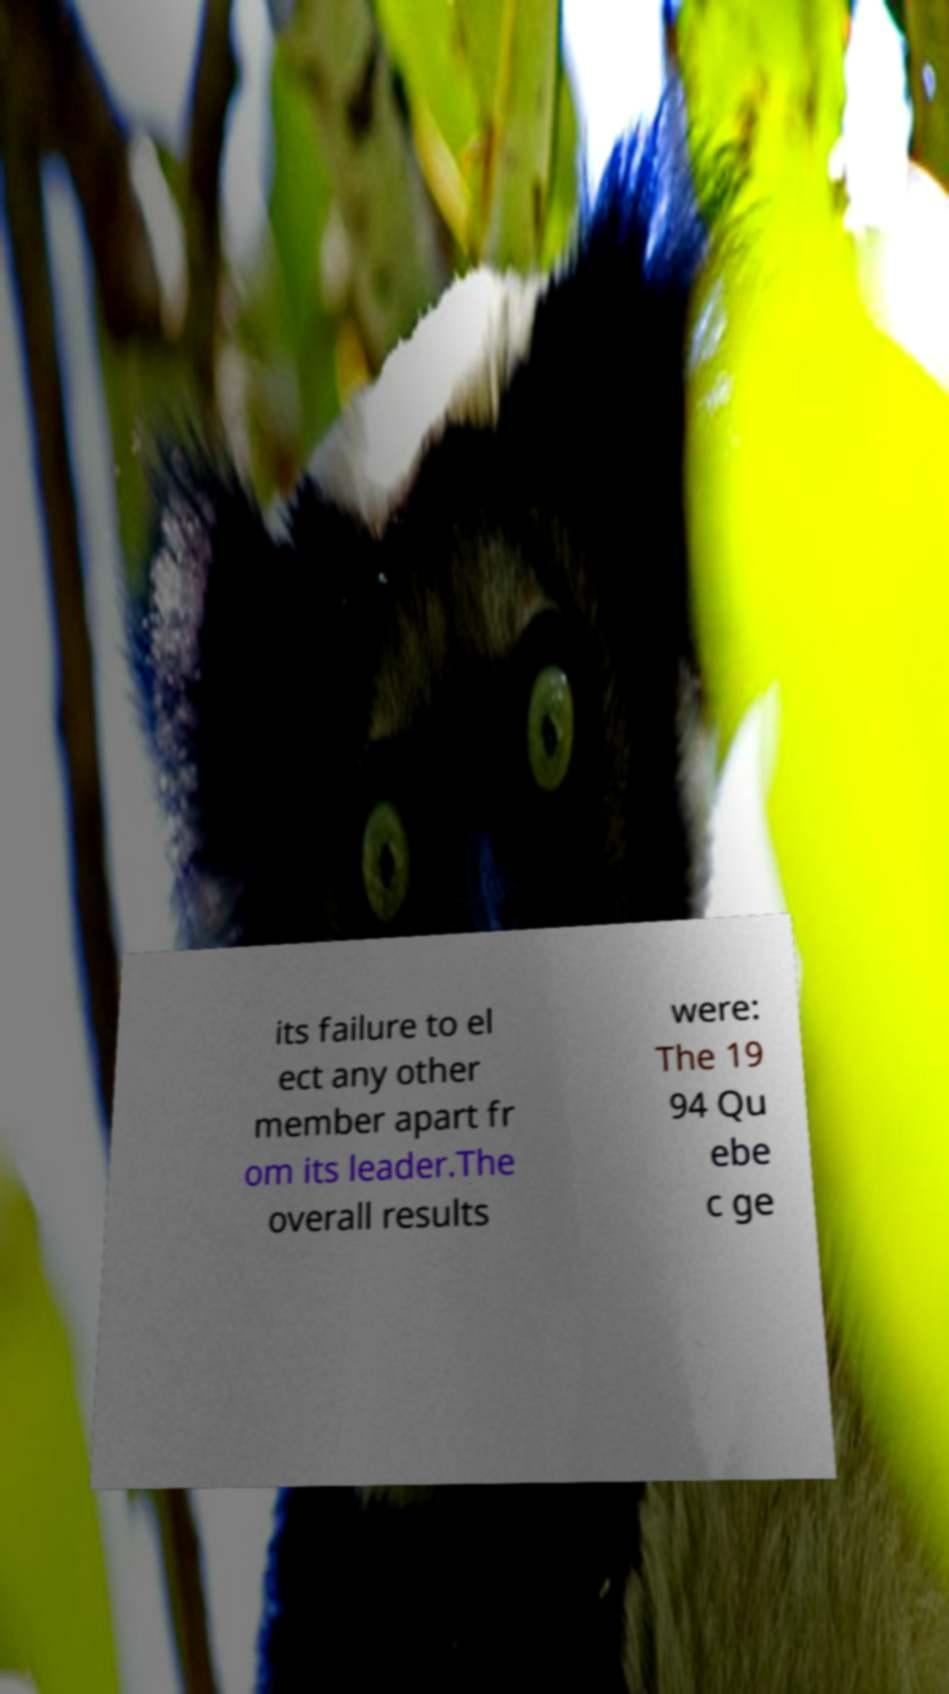Please identify and transcribe the text found in this image. its failure to el ect any other member apart fr om its leader.The overall results were: The 19 94 Qu ebe c ge 